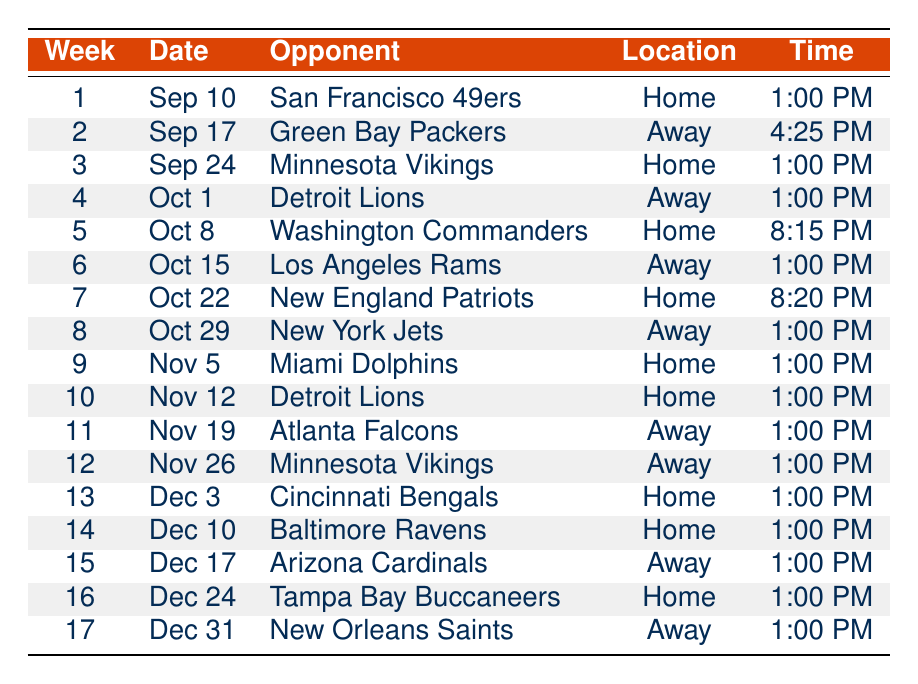What is the date of the game against the New England Patriots? The game against the New England Patriots is scheduled for the date indicated under Week 7, which is October 22, 2023.
Answer: October 22, 2023 How many home games are listed in the schedule? By reviewing the table, I count how many games have the location marked as "Home." Those games are against San Francisco 49ers (Week 1), Minnesota Vikings (Week 3), Washington Commanders (Week 5), New England Patriots (Week 7), Miami Dolphins (Week 9), Detroit Lions (Week 10), Cincinnati Bengals (Week 13), Baltimore Ravens (Week 14), Tampa Bay Buccaneers (Week 16). This totals to 9 home games.
Answer: 9 What time does the game against the Arizona Cardinals start? The game against the Arizona Cardinals is listed under Week 15, where the time is specified as 1:00 PM.
Answer: 1:00 PM Is there a game scheduled on December 10, 2023? No, the schedule indicates that there is a game on December 10, 2023, against the Baltimore Ravens.
Answer: Yes How many games are scheduled in October? To determine this, I check the weeks in the schedule where the month is listed as October: Week 4 (Detroit Lions), Week 5 (Washington Commanders), Week 6 (Los Angeles Rams), Week 7 (New England Patriots), and Week 8 (New York Jets). There are 5 games scheduled in October.
Answer: 5 Which opponent do the Bears face at home in Week 10, and what is the time of that game? In Week 10, the opponent is the Detroit Lions, and the scheduled time for this game is 1:00 PM.
Answer: Detroit Lions, 1:00 PM What is the result of the game against the Miami Dolphins? The result for the Miami Dolphins game is not available in the table, as it is marked as null and indicates that the game has not occurred yet.
Answer: Unknown In which week does Chicago Bears play their first away game? The first away game is against the Green Bay Packers, which is scheduled in Week 2.
Answer: Week 2 